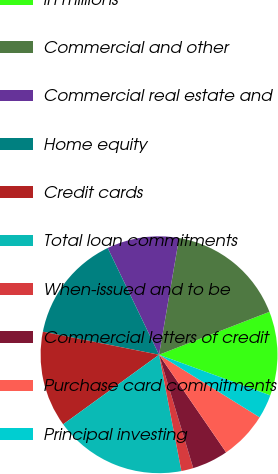Convert chart. <chart><loc_0><loc_0><loc_500><loc_500><pie_chart><fcel>in millions<fcel>Commercial and other<fcel>Commercial real estate and<fcel>Home equity<fcel>Credit cards<fcel>Total loan commitments<fcel>When-issued and to be<fcel>Commercial letters of credit<fcel>Purchase card commitments<fcel>Principal investing<nl><fcel>11.48%<fcel>16.39%<fcel>9.84%<fcel>14.75%<fcel>13.11%<fcel>18.03%<fcel>1.64%<fcel>4.92%<fcel>6.56%<fcel>3.28%<nl></chart> 